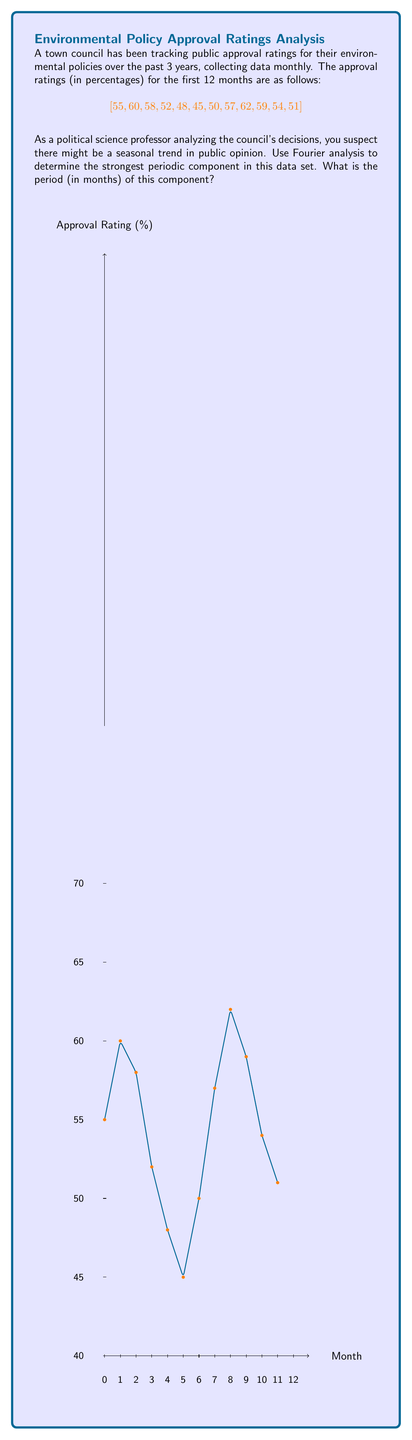Help me with this question. To solve this problem using Fourier analysis, we'll follow these steps:

1) First, we need to compute the Discrete Fourier Transform (DFT) of our data. For a sequence $x_n$ of length N, the DFT is given by:

   $$X_k = \sum_{n=0}^{N-1} x_n e^{-2\pi i k n / N}$$

   where $k = 0, 1, ..., N-1$

2) In our case, $N = 12$ (12 months of data). We'll compute $X_k$ for each $k$:

   $X_0 = 651$ (sum of all data points)
   $X_1 = -24.25 - 35.20i$
   $X_2 = 26.60 + 15.07i$
   $X_3 = -9.00 + 15.59i$
   $X_4 = 1.25 - 2.17i$
   $X_5 = 3.60 - 6.24i$
   $X_6 = 7.00$

   (Note: $X_7$ to $X_{11}$ are complex conjugates of $X_5$ to $X_1$ respectively)

3) The magnitude of each $X_k$ represents the strength of the corresponding frequency component:

   $|X_0| = 651$
   $|X_1| = 42.76$
   $|X_2| = 30.55$
   $|X_3| = 18.01$
   $|X_4| = 2.51$
   $|X_5| = 7.20$
   $|X_6| = 7.00$

4) The strongest component (excluding $X_0$ which represents the DC component) is $|X_1| = 42.76$

5) The frequency corresponding to $X_1$ is $f_1 = 1/12$ cycles per month

6) The period is the reciprocal of the frequency:

   $$T = \frac{1}{f_1} = \frac{1}{1/12} = 12\text{ months}$$

Therefore, the strongest periodic component has a period of 12 months, indicating an annual cycle in public opinion.
Answer: 12 months 